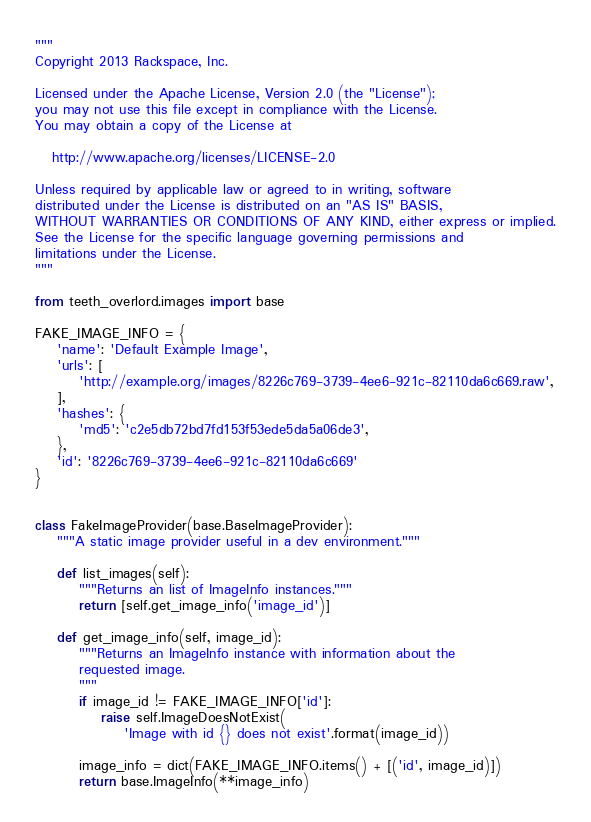<code> <loc_0><loc_0><loc_500><loc_500><_Python_>"""
Copyright 2013 Rackspace, Inc.

Licensed under the Apache License, Version 2.0 (the "License");
you may not use this file except in compliance with the License.
You may obtain a copy of the License at

   http://www.apache.org/licenses/LICENSE-2.0

Unless required by applicable law or agreed to in writing, software
distributed under the License is distributed on an "AS IS" BASIS,
WITHOUT WARRANTIES OR CONDITIONS OF ANY KIND, either express or implied.
See the License for the specific language governing permissions and
limitations under the License.
"""

from teeth_overlord.images import base

FAKE_IMAGE_INFO = {
    'name': 'Default Example Image',
    'urls': [
        'http://example.org/images/8226c769-3739-4ee6-921c-82110da6c669.raw',
    ],
    'hashes': {
        'md5': 'c2e5db72bd7fd153f53ede5da5a06de3',
    },
    'id': '8226c769-3739-4ee6-921c-82110da6c669'
}


class FakeImageProvider(base.BaseImageProvider):
    """A static image provider useful in a dev environment."""

    def list_images(self):
        """Returns an list of ImageInfo instances."""
        return [self.get_image_info('image_id')]

    def get_image_info(self, image_id):
        """Returns an ImageInfo instance with information about the
        requested image.
        """
        if image_id != FAKE_IMAGE_INFO['id']:
            raise self.ImageDoesNotExist(
                'Image with id {} does not exist'.format(image_id))

        image_info = dict(FAKE_IMAGE_INFO.items() + [('id', image_id)])
        return base.ImageInfo(**image_info)
</code> 